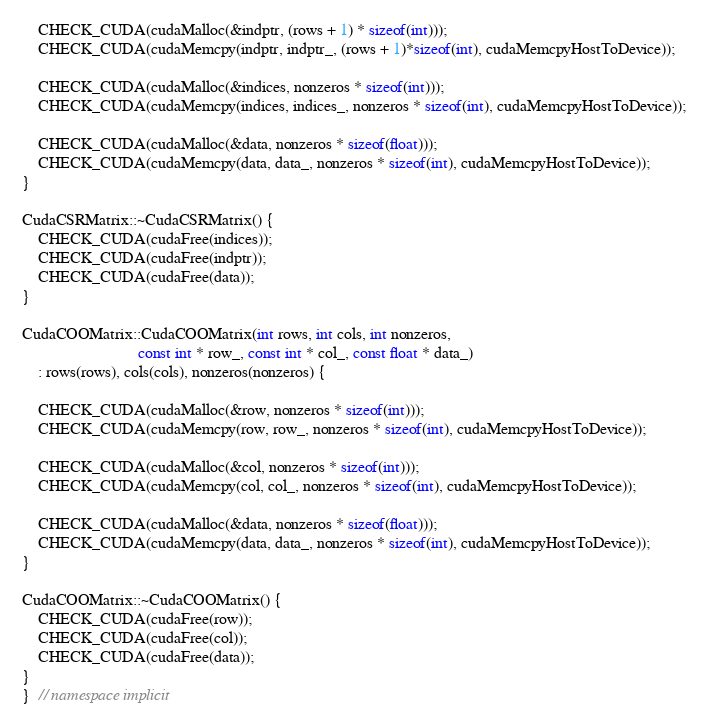<code> <loc_0><loc_0><loc_500><loc_500><_Cuda_>
    CHECK_CUDA(cudaMalloc(&indptr, (rows + 1) * sizeof(int)));
    CHECK_CUDA(cudaMemcpy(indptr, indptr_, (rows + 1)*sizeof(int), cudaMemcpyHostToDevice));

    CHECK_CUDA(cudaMalloc(&indices, nonzeros * sizeof(int)));
    CHECK_CUDA(cudaMemcpy(indices, indices_, nonzeros * sizeof(int), cudaMemcpyHostToDevice));

    CHECK_CUDA(cudaMalloc(&data, nonzeros * sizeof(float)));
    CHECK_CUDA(cudaMemcpy(data, data_, nonzeros * sizeof(int), cudaMemcpyHostToDevice));
}

CudaCSRMatrix::~CudaCSRMatrix() {
    CHECK_CUDA(cudaFree(indices));
    CHECK_CUDA(cudaFree(indptr));
    CHECK_CUDA(cudaFree(data));
}

CudaCOOMatrix::CudaCOOMatrix(int rows, int cols, int nonzeros,
                             const int * row_, const int * col_, const float * data_)
    : rows(rows), cols(cols), nonzeros(nonzeros) {

    CHECK_CUDA(cudaMalloc(&row, nonzeros * sizeof(int)));
    CHECK_CUDA(cudaMemcpy(row, row_, nonzeros * sizeof(int), cudaMemcpyHostToDevice));

    CHECK_CUDA(cudaMalloc(&col, nonzeros * sizeof(int)));
    CHECK_CUDA(cudaMemcpy(col, col_, nonzeros * sizeof(int), cudaMemcpyHostToDevice));

    CHECK_CUDA(cudaMalloc(&data, nonzeros * sizeof(float)));
    CHECK_CUDA(cudaMemcpy(data, data_, nonzeros * sizeof(int), cudaMemcpyHostToDevice));
}

CudaCOOMatrix::~CudaCOOMatrix() {
    CHECK_CUDA(cudaFree(row));
    CHECK_CUDA(cudaFree(col));
    CHECK_CUDA(cudaFree(data));
}
}  // namespace implicit
</code> 